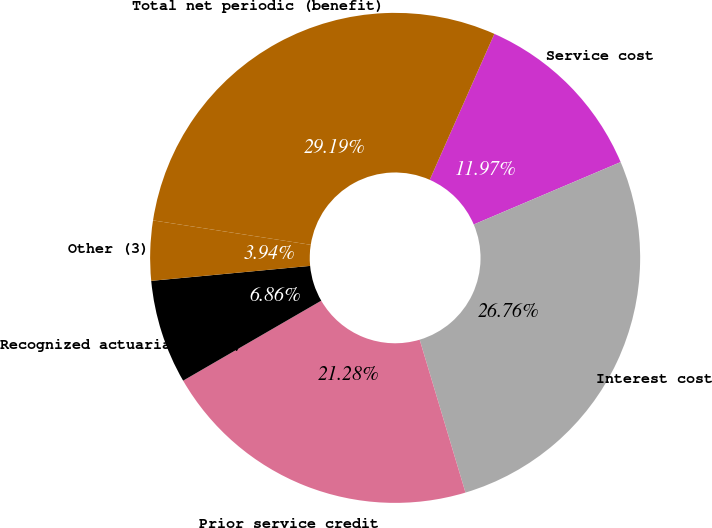Convert chart. <chart><loc_0><loc_0><loc_500><loc_500><pie_chart><fcel>Service cost<fcel>Interest cost<fcel>Prior service credit<fcel>Recognized actuarial (gain)<fcel>Other (3)<fcel>Total net periodic (benefit)<nl><fcel>11.97%<fcel>26.76%<fcel>21.28%<fcel>6.86%<fcel>3.94%<fcel>29.19%<nl></chart> 